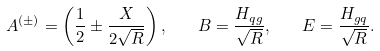Convert formula to latex. <formula><loc_0><loc_0><loc_500><loc_500>A ^ { ( \pm ) } = \left ( \frac { 1 } { 2 } \pm \frac { X } { 2 \sqrt { R } } \right ) , \quad B = \frac { H _ { q g } } { \sqrt { R } } , \quad E = \frac { H _ { g q } } { \sqrt { R } } .</formula> 